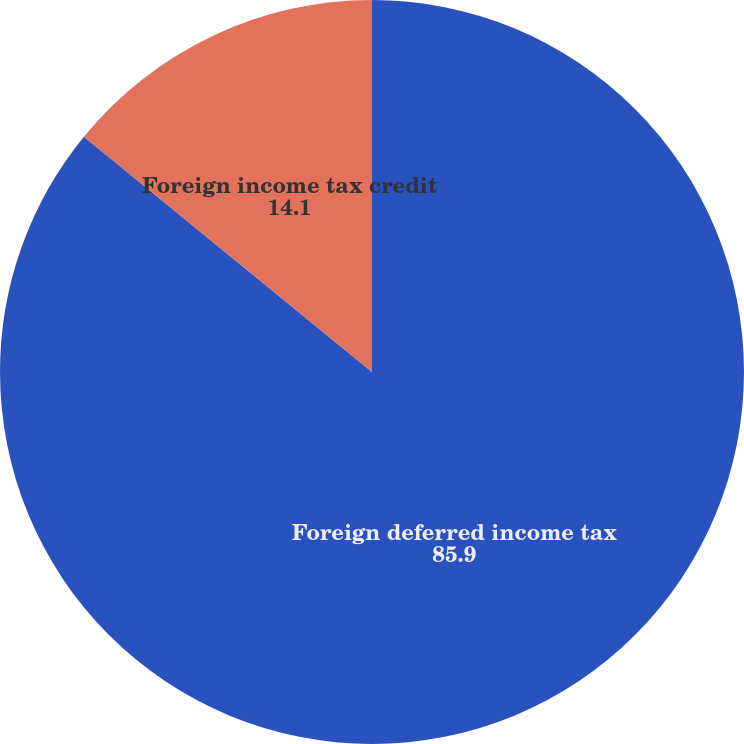Convert chart to OTSL. <chart><loc_0><loc_0><loc_500><loc_500><pie_chart><fcel>Foreign deferred income tax<fcel>Foreign income tax credit<nl><fcel>85.9%<fcel>14.1%<nl></chart> 